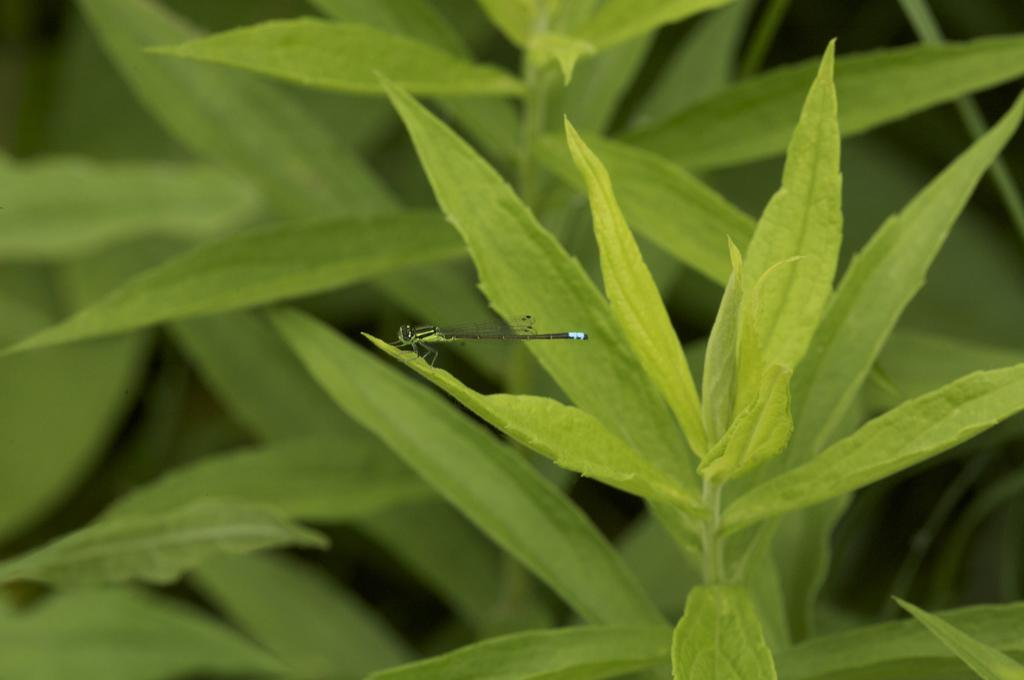What is present in the image? There is a fly in the image. Where is the fly located? The fly is standing on the leaf of a plant. What type of toothbrush is the fly using in the image? There is no toothbrush present in the image. 